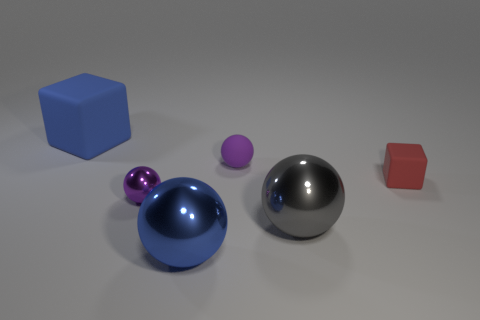What number of matte blocks are there?
Offer a terse response. 2. What number of small objects are red cylinders or blocks?
Make the answer very short. 1. What is the color of the block that is behind the cube that is in front of the matte thing on the left side of the tiny purple shiny object?
Provide a succinct answer. Blue. How many other things are there of the same color as the small matte block?
Provide a short and direct response. 0. How many matte things are either big cyan cylinders or small objects?
Offer a terse response. 2. Do the small rubber thing on the right side of the tiny purple rubber thing and the tiny thing behind the red object have the same color?
Keep it short and to the point. No. Are there any other things that have the same material as the big gray object?
Your answer should be compact. Yes. The other object that is the same shape as the big blue matte object is what size?
Offer a terse response. Small. Is the number of large gray spheres to the right of the small red rubber thing greater than the number of tiny purple things?
Provide a short and direct response. No. Are the block left of the gray ball and the gray sphere made of the same material?
Provide a succinct answer. No. 